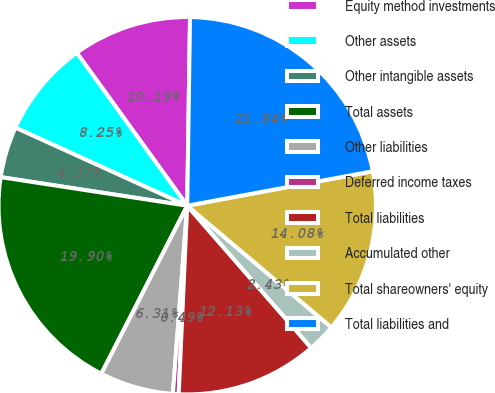Convert chart. <chart><loc_0><loc_0><loc_500><loc_500><pie_chart><fcel>Equity method investments<fcel>Other assets<fcel>Other intangible assets<fcel>Total assets<fcel>Other liabilities<fcel>Deferred income taxes<fcel>Total liabilities<fcel>Accumulated other<fcel>Total shareowners' equity<fcel>Total liabilities and<nl><fcel>10.19%<fcel>8.25%<fcel>4.37%<fcel>19.89%<fcel>6.31%<fcel>0.49%<fcel>12.13%<fcel>2.43%<fcel>14.07%<fcel>21.83%<nl></chart> 